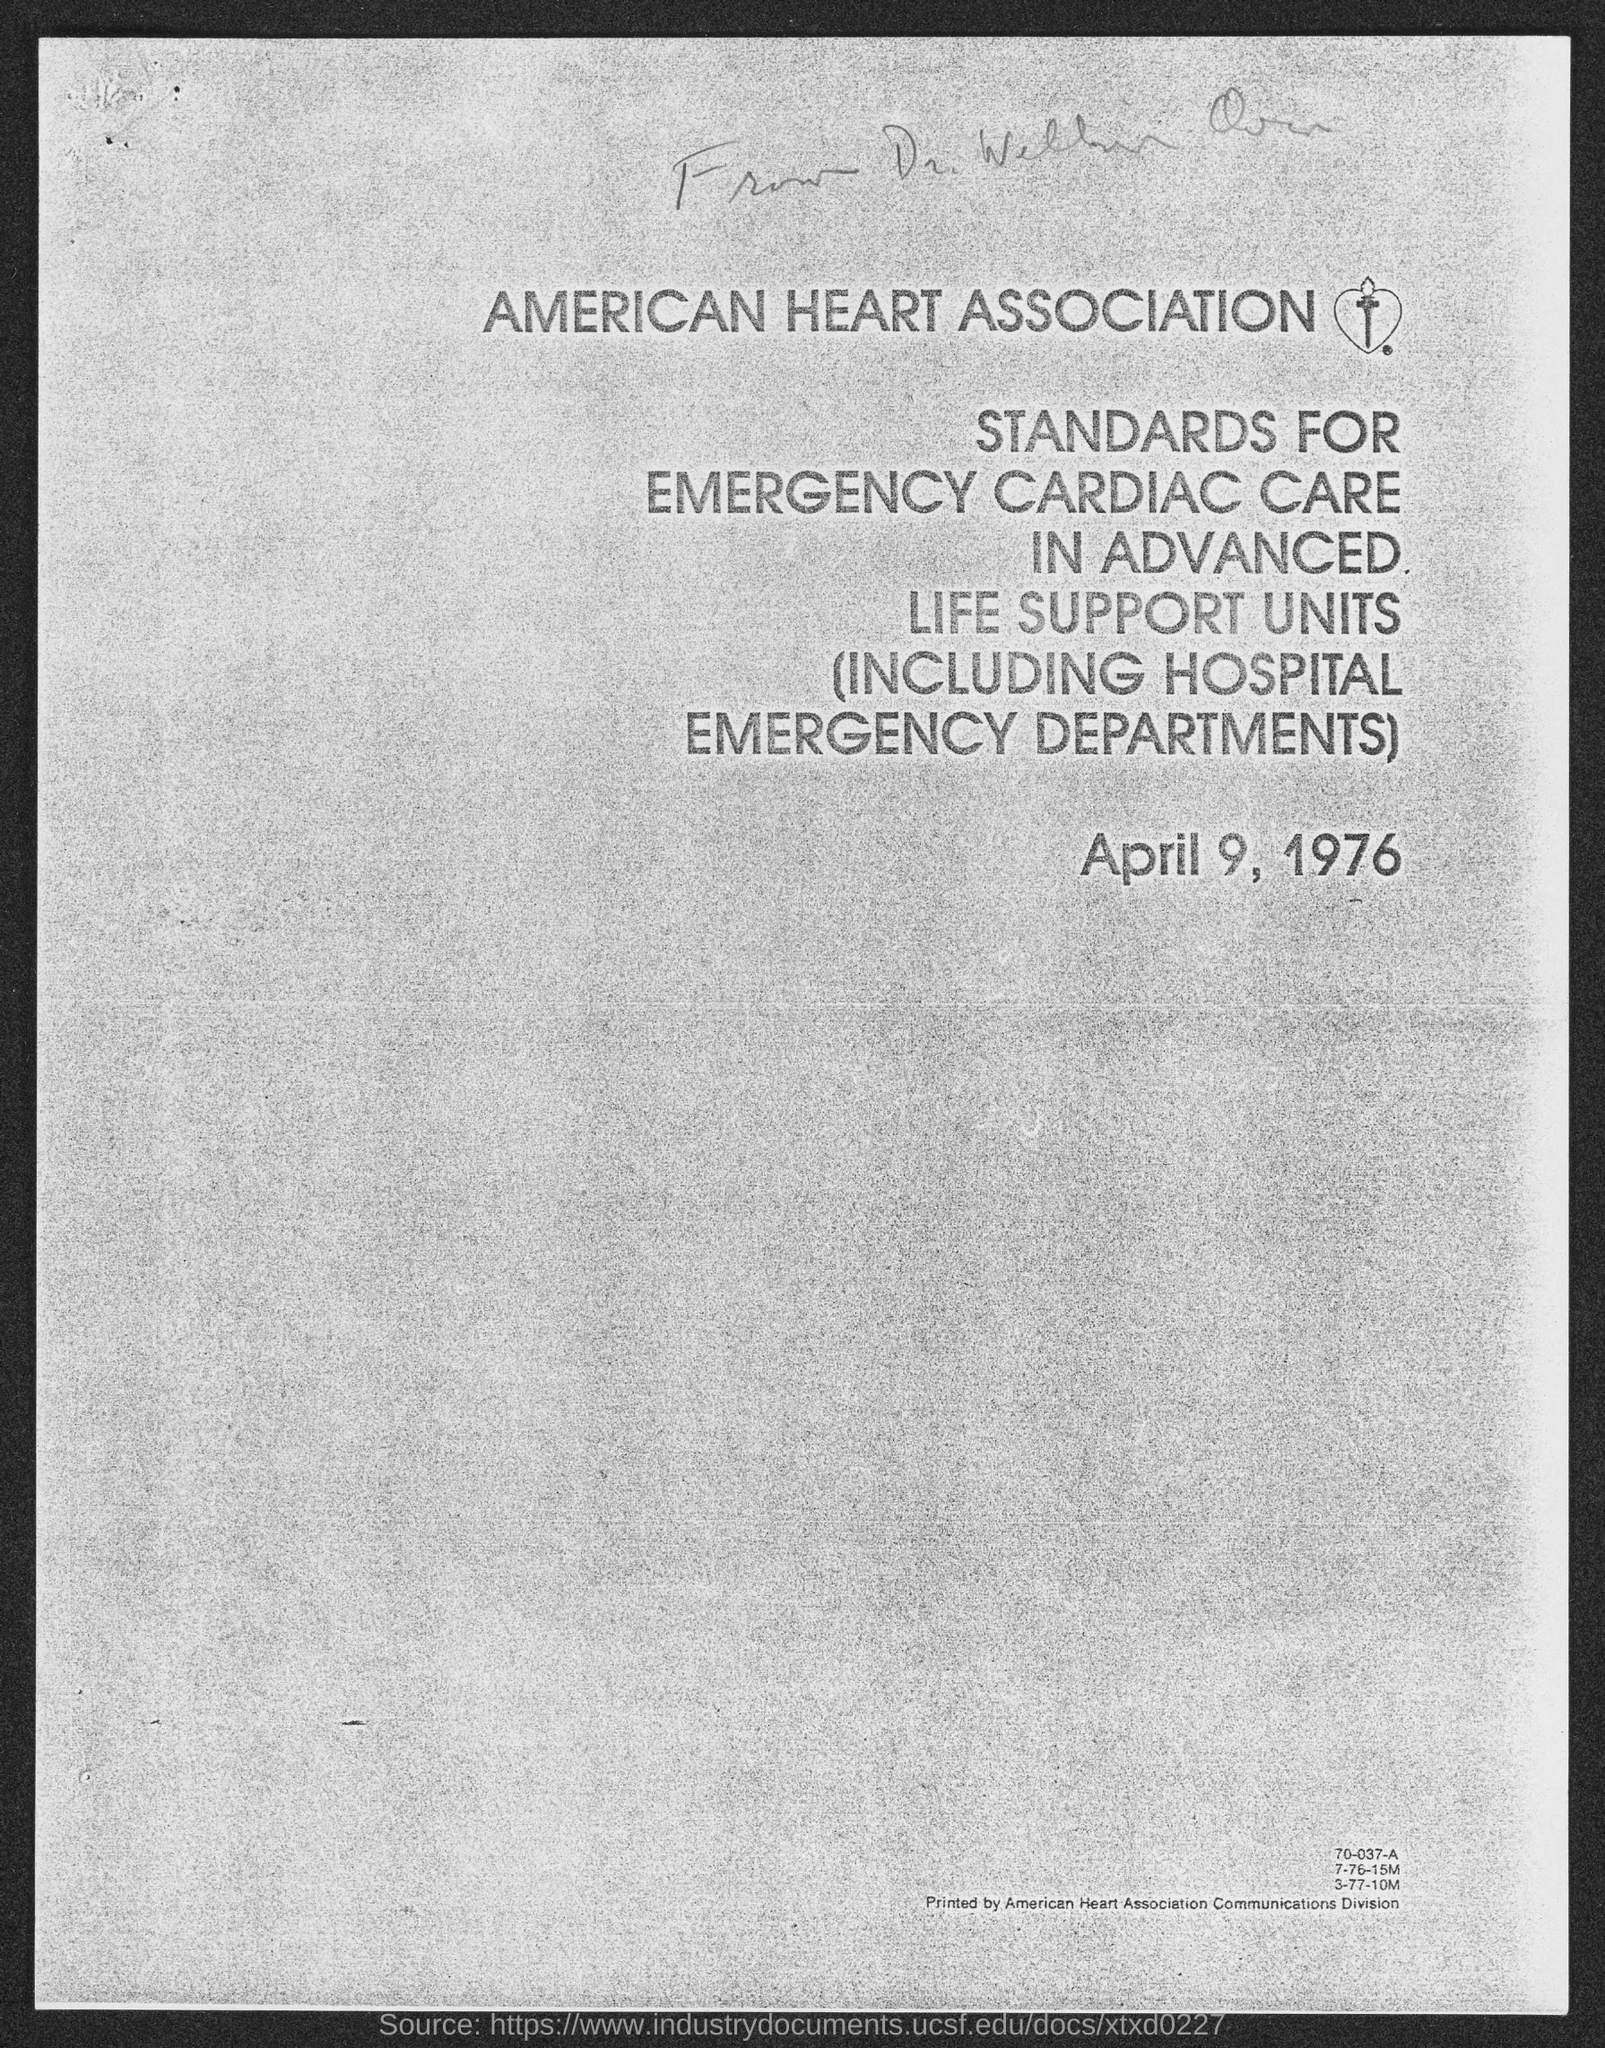What is the name of health association given ?
Ensure brevity in your answer.  American Heart Association. 